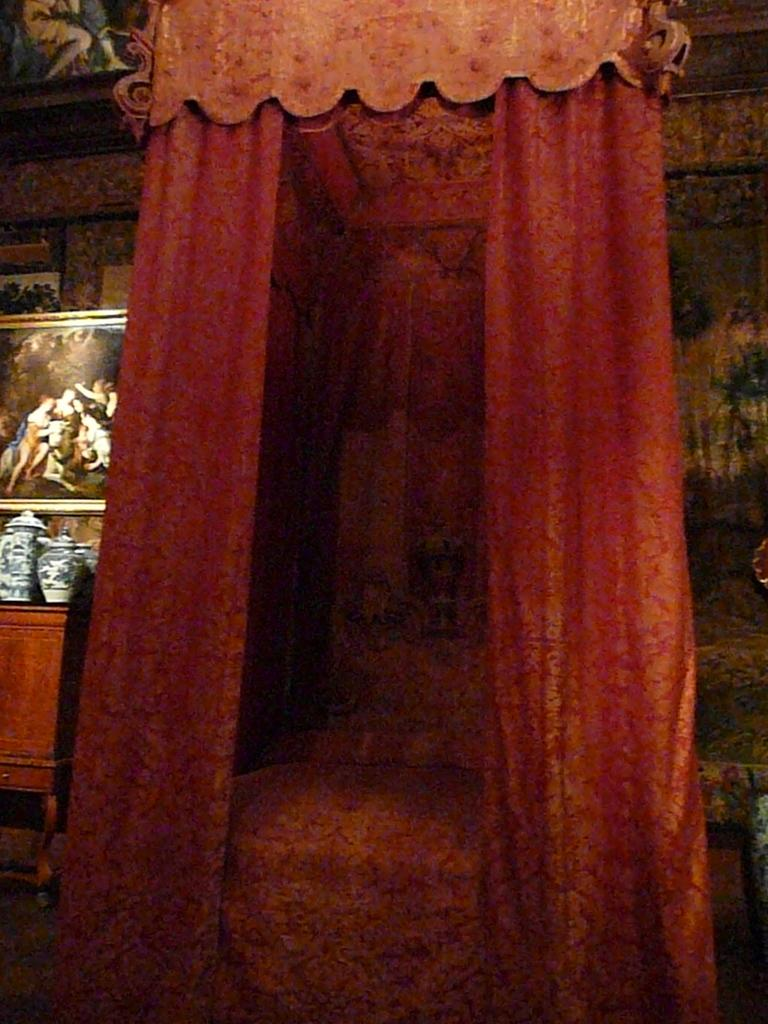What is the main structure in the image? There is a chamber in the image. What can be found inside the chamber? The chamber contains curtains. What is hanging on the wall in the image? There is a photo frame on the wall. What objects are on the table in the image? There are jars on a table. Where is the table located in the image? The table is on the left side of the image. What type of disease is being treated in the chamber in the image? There is no indication of a disease or any medical treatment in the image; it features a chamber with curtains, a photo frame, and a table with jars. Can you see a scarecrow in the image? No, there is no scarecrow present in the image. 